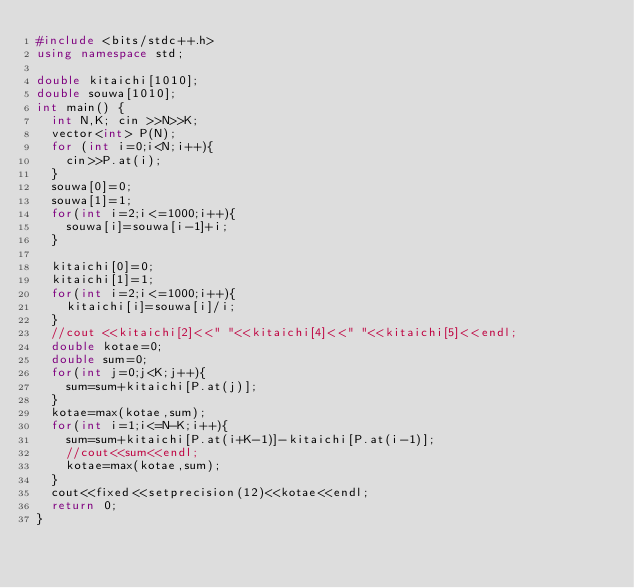Convert code to text. <code><loc_0><loc_0><loc_500><loc_500><_C++_>#include <bits/stdc++.h>
using namespace std;

double kitaichi[1010];
double souwa[1010];
int main() {
  int N,K; cin >>N>>K;
  vector<int> P(N);
  for (int i=0;i<N;i++){
    cin>>P.at(i);
  }
  souwa[0]=0;
  souwa[1]=1;
  for(int i=2;i<=1000;i++){
    souwa[i]=souwa[i-1]+i;
  }
 
  kitaichi[0]=0;
  kitaichi[1]=1;
  for(int i=2;i<=1000;i++){
    kitaichi[i]=souwa[i]/i;
  }
  //cout <<kitaichi[2]<<" "<<kitaichi[4]<<" "<<kitaichi[5]<<endl;
  double kotae=0;
  double sum=0;
  for(int j=0;j<K;j++){
    sum=sum+kitaichi[P.at(j)];
  }
  kotae=max(kotae,sum);
  for(int i=1;i<=N-K;i++){  
    sum=sum+kitaichi[P.at(i+K-1)]-kitaichi[P.at(i-1)];
    //cout<<sum<<endl;
    kotae=max(kotae,sum);
  }
  cout<<fixed<<setprecision(12)<<kotae<<endl;
  return 0;
}</code> 